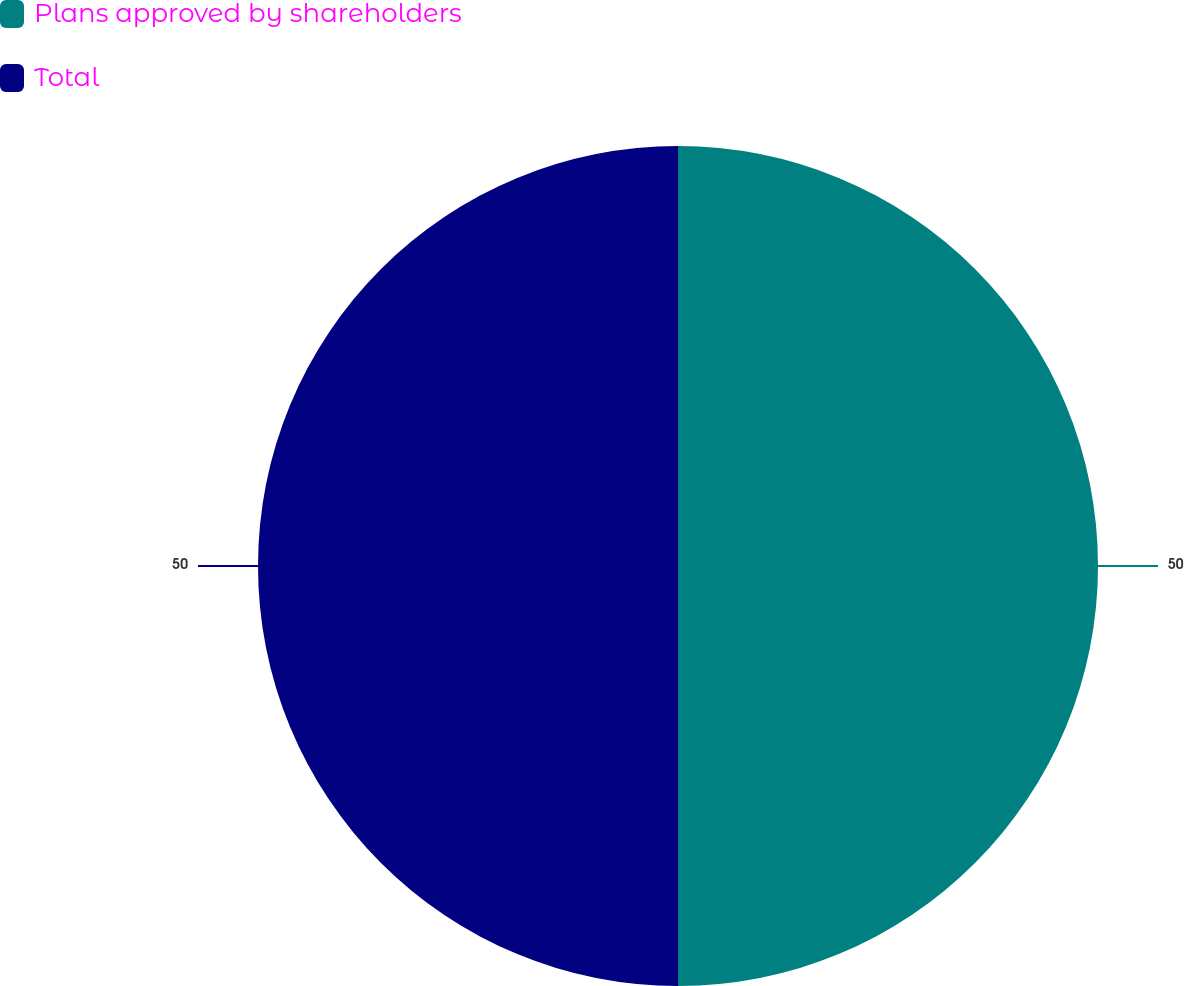Convert chart. <chart><loc_0><loc_0><loc_500><loc_500><pie_chart><fcel>Plans approved by shareholders<fcel>Total<nl><fcel>50.0%<fcel>50.0%<nl></chart> 